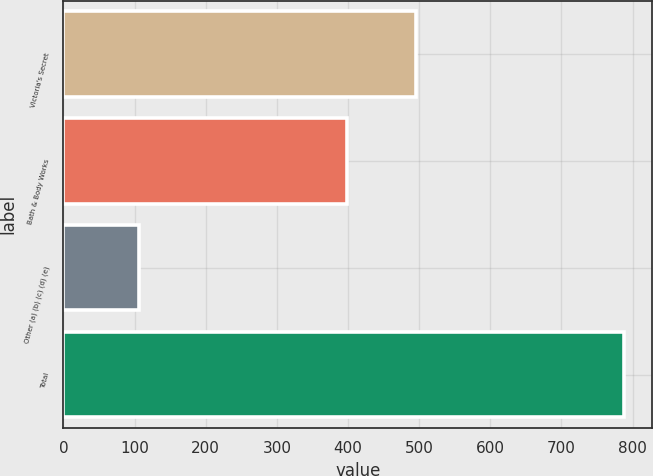Convert chart to OTSL. <chart><loc_0><loc_0><loc_500><loc_500><bar_chart><fcel>Victoria's Secret<fcel>Bath & Body Works<fcel>Other (a) (b) (c) (d) (e)<fcel>Total<nl><fcel>496<fcel>398<fcel>106<fcel>788<nl></chart> 